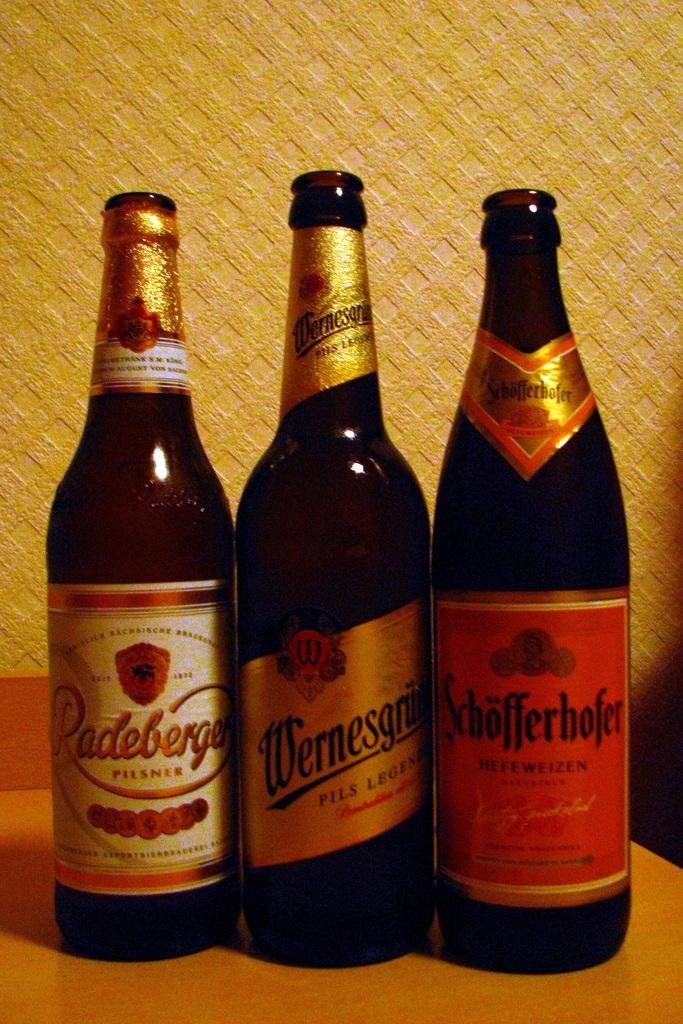<image>
Give a short and clear explanation of the subsequent image. Three different bottles of beer, including a Pilsner and a Hefeweizen. 